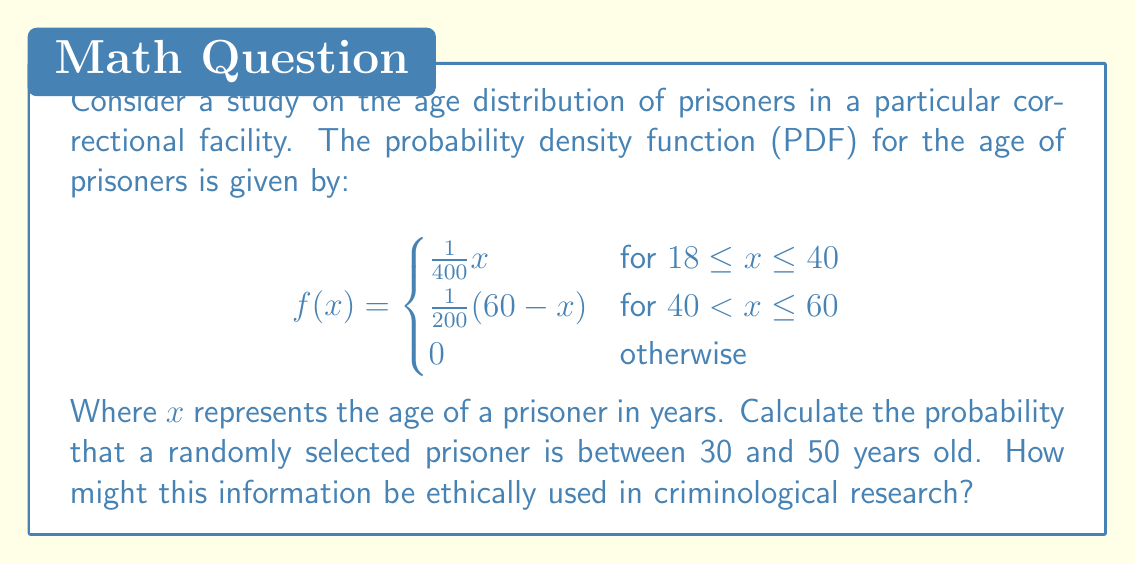Show me your answer to this math problem. To solve this problem, we need to integrate the probability density function over the given interval [30, 50]. This interval spans both pieces of the piecewise function, so we'll need to split the integral into two parts.

1. For the interval [30, 40]:
   $$\int_{30}^{40} \frac{1}{400}x dx$$

2. For the interval (40, 50]:
   $$\int_{40}^{50} \frac{1}{200}(60-x) dx$$

Let's calculate each part:

1. $$\int_{30}^{40} \frac{1}{400}x dx = \frac{1}{400} \cdot \frac{x^2}{2} \bigg|_{30}^{40} = \frac{1}{800}(40^2 - 30^2) = \frac{1}{800}(1600 - 900) = \frac{700}{800} = 0.875$$

2. $$\int_{40}^{50} \frac{1}{200}(60-x) dx = \frac{1}{200}(60x - \frac{x^2}{2}) \bigg|_{40}^{50} = \frac{1}{200}[(3000 - 1250) - (2400 - 800)] = \frac{150}{200} = 0.75$$

The total probability is the sum of these two parts:
$$0.875 + 0.75 = 1.625$$

Ethical considerations: This information could be used to understand age demographics in prisons, which might inform rehabilitation programs or health care services. However, researchers must be cautious not to use this data to discriminate against certain age groups or to make broad generalizations about criminal behavior based solely on age.
Answer: The probability that a randomly selected prisoner is between 30 and 50 years old is 1.625 or 162.5%. 